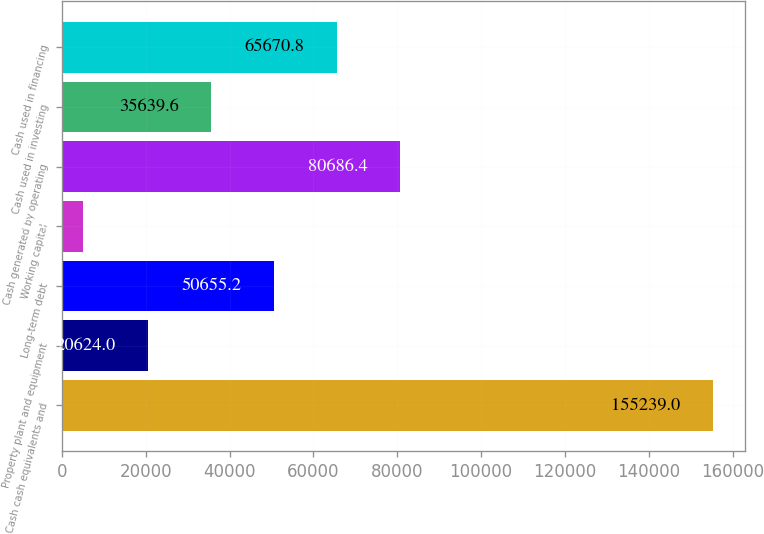Convert chart. <chart><loc_0><loc_0><loc_500><loc_500><bar_chart><fcel>Cash cash equivalents and<fcel>Property plant and equipment<fcel>Long-term debt<fcel>Working capital<fcel>Cash generated by operating<fcel>Cash used in investing<fcel>Cash used in financing<nl><fcel>155239<fcel>20624<fcel>50655.2<fcel>5083<fcel>80686.4<fcel>35639.6<fcel>65670.8<nl></chart> 